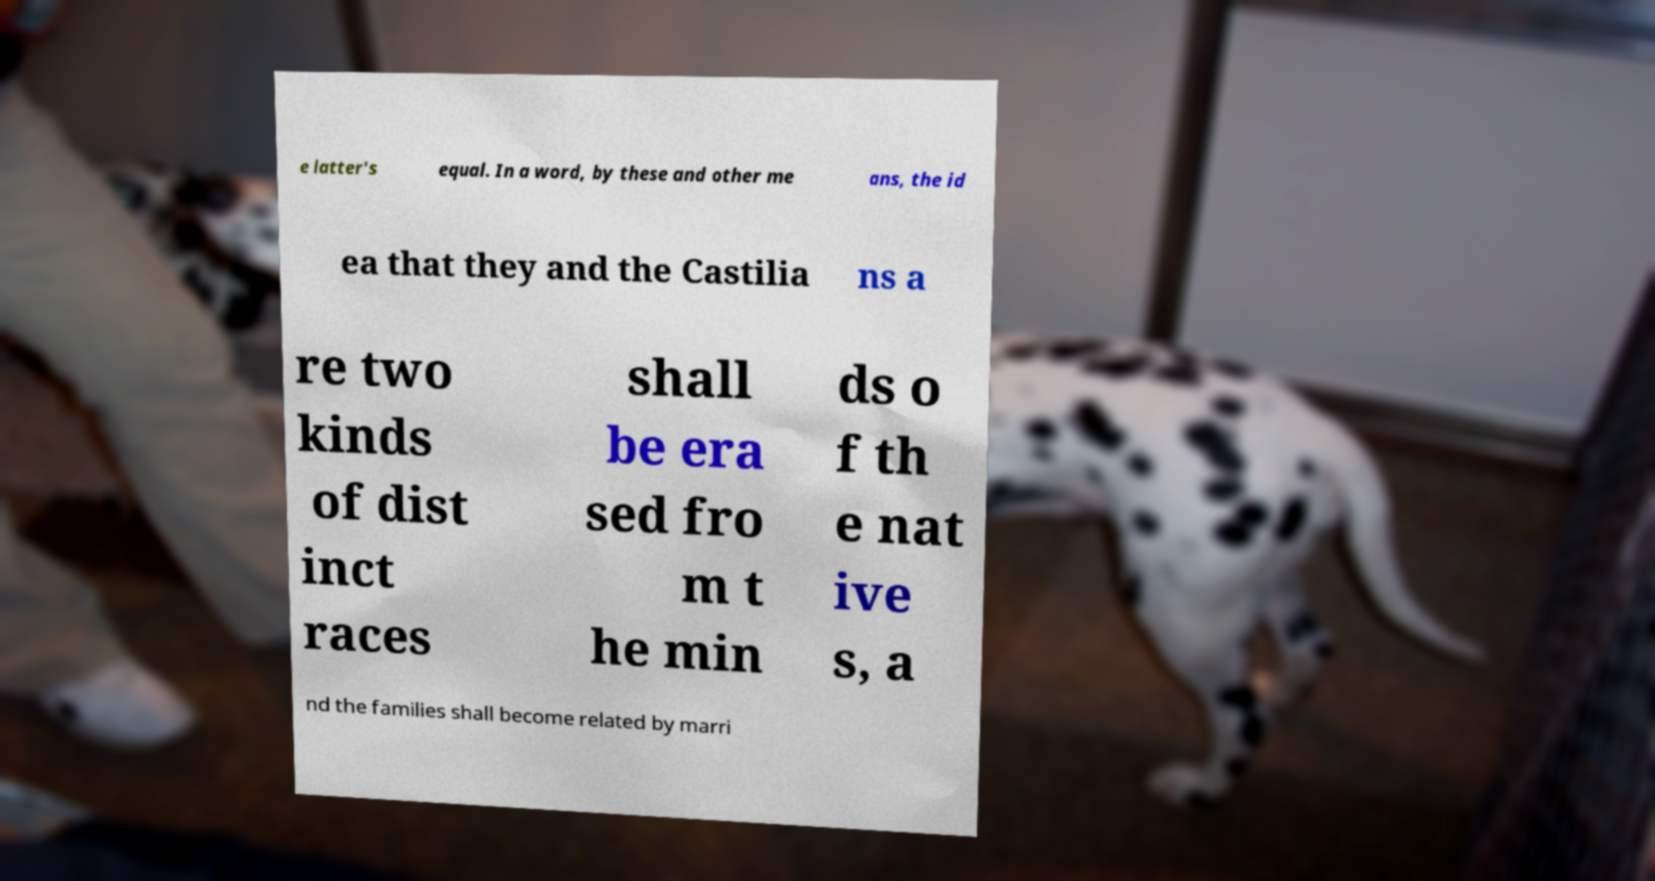Can you read and provide the text displayed in the image?This photo seems to have some interesting text. Can you extract and type it out for me? e latter's equal. In a word, by these and other me ans, the id ea that they and the Castilia ns a re two kinds of dist inct races shall be era sed fro m t he min ds o f th e nat ive s, a nd the families shall become related by marri 